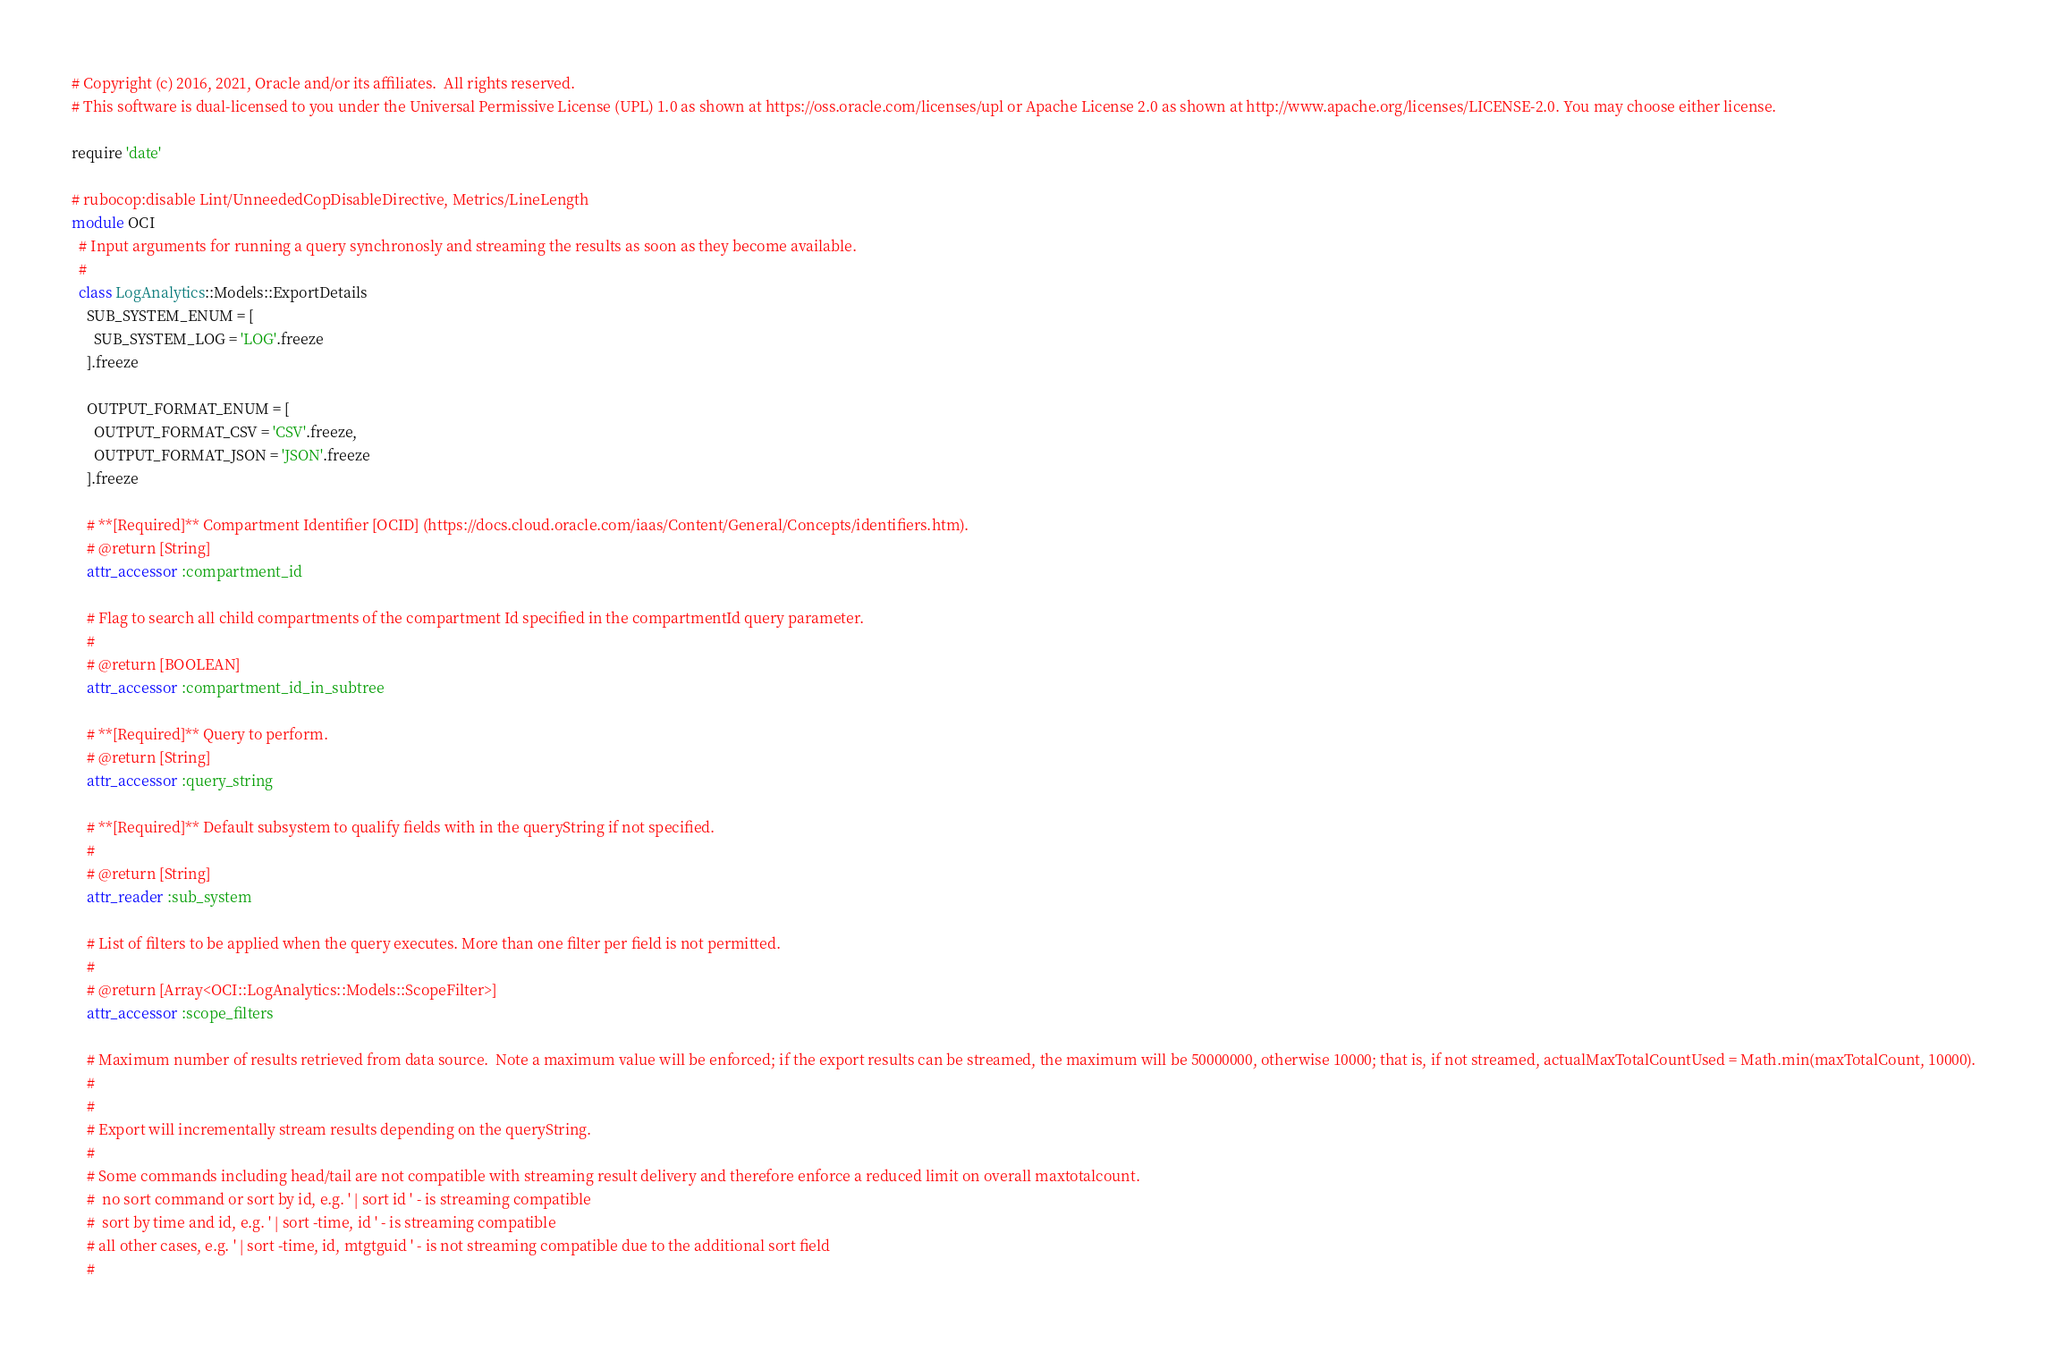<code> <loc_0><loc_0><loc_500><loc_500><_Ruby_># Copyright (c) 2016, 2021, Oracle and/or its affiliates.  All rights reserved.
# This software is dual-licensed to you under the Universal Permissive License (UPL) 1.0 as shown at https://oss.oracle.com/licenses/upl or Apache License 2.0 as shown at http://www.apache.org/licenses/LICENSE-2.0. You may choose either license.

require 'date'

# rubocop:disable Lint/UnneededCopDisableDirective, Metrics/LineLength
module OCI
  # Input arguments for running a query synchronosly and streaming the results as soon as they become available.
  #
  class LogAnalytics::Models::ExportDetails
    SUB_SYSTEM_ENUM = [
      SUB_SYSTEM_LOG = 'LOG'.freeze
    ].freeze

    OUTPUT_FORMAT_ENUM = [
      OUTPUT_FORMAT_CSV = 'CSV'.freeze,
      OUTPUT_FORMAT_JSON = 'JSON'.freeze
    ].freeze

    # **[Required]** Compartment Identifier [OCID] (https://docs.cloud.oracle.com/iaas/Content/General/Concepts/identifiers.htm).
    # @return [String]
    attr_accessor :compartment_id

    # Flag to search all child compartments of the compartment Id specified in the compartmentId query parameter.
    #
    # @return [BOOLEAN]
    attr_accessor :compartment_id_in_subtree

    # **[Required]** Query to perform.
    # @return [String]
    attr_accessor :query_string

    # **[Required]** Default subsystem to qualify fields with in the queryString if not specified.
    #
    # @return [String]
    attr_reader :sub_system

    # List of filters to be applied when the query executes. More than one filter per field is not permitted.
    #
    # @return [Array<OCI::LogAnalytics::Models::ScopeFilter>]
    attr_accessor :scope_filters

    # Maximum number of results retrieved from data source.  Note a maximum value will be enforced; if the export results can be streamed, the maximum will be 50000000, otherwise 10000; that is, if not streamed, actualMaxTotalCountUsed = Math.min(maxTotalCount, 10000).
    #
    #
    # Export will incrementally stream results depending on the queryString.
    #
    # Some commands including head/tail are not compatible with streaming result delivery and therefore enforce a reduced limit on overall maxtotalcount.
    #  no sort command or sort by id, e.g. ' | sort id ' - is streaming compatible
    #  sort by time and id, e.g. ' | sort -time, id ' - is streaming compatible
    # all other cases, e.g. ' | sort -time, id, mtgtguid ' - is not streaming compatible due to the additional sort field
    #</code> 